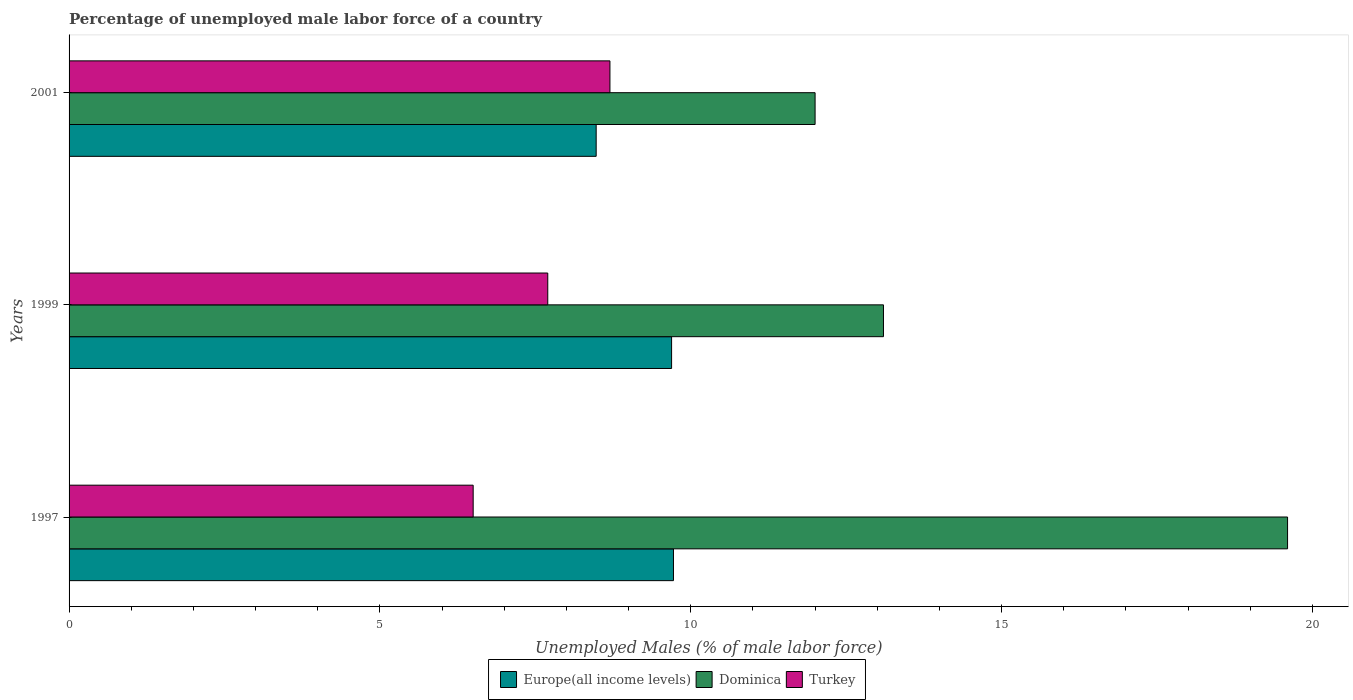How many different coloured bars are there?
Your answer should be compact. 3. How many groups of bars are there?
Your answer should be very brief. 3. Are the number of bars on each tick of the Y-axis equal?
Your answer should be compact. Yes. How many bars are there on the 2nd tick from the bottom?
Make the answer very short. 3. What is the label of the 3rd group of bars from the top?
Offer a very short reply. 1997. In how many cases, is the number of bars for a given year not equal to the number of legend labels?
Offer a very short reply. 0. What is the percentage of unemployed male labor force in Europe(all income levels) in 1997?
Give a very brief answer. 9.72. Across all years, what is the maximum percentage of unemployed male labor force in Dominica?
Ensure brevity in your answer.  19.6. Across all years, what is the minimum percentage of unemployed male labor force in Turkey?
Keep it short and to the point. 6.5. What is the total percentage of unemployed male labor force in Turkey in the graph?
Offer a very short reply. 22.9. What is the difference between the percentage of unemployed male labor force in Europe(all income levels) in 1997 and that in 1999?
Offer a very short reply. 0.03. What is the difference between the percentage of unemployed male labor force in Europe(all income levels) in 1997 and the percentage of unemployed male labor force in Dominica in 1999?
Offer a very short reply. -3.38. What is the average percentage of unemployed male labor force in Turkey per year?
Keep it short and to the point. 7.63. In the year 1999, what is the difference between the percentage of unemployed male labor force in Europe(all income levels) and percentage of unemployed male labor force in Turkey?
Ensure brevity in your answer.  1.99. What is the ratio of the percentage of unemployed male labor force in Europe(all income levels) in 1997 to that in 2001?
Offer a very short reply. 1.15. Is the percentage of unemployed male labor force in Turkey in 1997 less than that in 1999?
Make the answer very short. Yes. Is the difference between the percentage of unemployed male labor force in Europe(all income levels) in 1997 and 2001 greater than the difference between the percentage of unemployed male labor force in Turkey in 1997 and 2001?
Your answer should be compact. Yes. What is the difference between the highest and the second highest percentage of unemployed male labor force in Turkey?
Provide a succinct answer. 1. What is the difference between the highest and the lowest percentage of unemployed male labor force in Dominica?
Provide a succinct answer. 7.6. In how many years, is the percentage of unemployed male labor force in Dominica greater than the average percentage of unemployed male labor force in Dominica taken over all years?
Your answer should be very brief. 1. What does the 2nd bar from the bottom in 2001 represents?
Your answer should be compact. Dominica. Is it the case that in every year, the sum of the percentage of unemployed male labor force in Turkey and percentage of unemployed male labor force in Dominica is greater than the percentage of unemployed male labor force in Europe(all income levels)?
Your answer should be very brief. Yes. How many bars are there?
Offer a very short reply. 9. What is the difference between two consecutive major ticks on the X-axis?
Provide a short and direct response. 5. Does the graph contain any zero values?
Provide a succinct answer. No. Does the graph contain grids?
Offer a terse response. No. What is the title of the graph?
Offer a terse response. Percentage of unemployed male labor force of a country. What is the label or title of the X-axis?
Ensure brevity in your answer.  Unemployed Males (% of male labor force). What is the label or title of the Y-axis?
Your response must be concise. Years. What is the Unemployed Males (% of male labor force) of Europe(all income levels) in 1997?
Ensure brevity in your answer.  9.72. What is the Unemployed Males (% of male labor force) in Dominica in 1997?
Your answer should be compact. 19.6. What is the Unemployed Males (% of male labor force) of Turkey in 1997?
Ensure brevity in your answer.  6.5. What is the Unemployed Males (% of male labor force) of Europe(all income levels) in 1999?
Your answer should be compact. 9.69. What is the Unemployed Males (% of male labor force) in Dominica in 1999?
Offer a very short reply. 13.1. What is the Unemployed Males (% of male labor force) in Turkey in 1999?
Your response must be concise. 7.7. What is the Unemployed Males (% of male labor force) in Europe(all income levels) in 2001?
Ensure brevity in your answer.  8.48. What is the Unemployed Males (% of male labor force) in Turkey in 2001?
Offer a very short reply. 8.7. Across all years, what is the maximum Unemployed Males (% of male labor force) of Europe(all income levels)?
Your response must be concise. 9.72. Across all years, what is the maximum Unemployed Males (% of male labor force) of Dominica?
Give a very brief answer. 19.6. Across all years, what is the maximum Unemployed Males (% of male labor force) in Turkey?
Make the answer very short. 8.7. Across all years, what is the minimum Unemployed Males (% of male labor force) of Europe(all income levels)?
Give a very brief answer. 8.48. Across all years, what is the minimum Unemployed Males (% of male labor force) in Dominica?
Your response must be concise. 12. What is the total Unemployed Males (% of male labor force) of Europe(all income levels) in the graph?
Keep it short and to the point. 27.89. What is the total Unemployed Males (% of male labor force) in Dominica in the graph?
Make the answer very short. 44.7. What is the total Unemployed Males (% of male labor force) of Turkey in the graph?
Keep it short and to the point. 22.9. What is the difference between the Unemployed Males (% of male labor force) in Europe(all income levels) in 1997 and that in 1999?
Your response must be concise. 0.03. What is the difference between the Unemployed Males (% of male labor force) in Dominica in 1997 and that in 1999?
Offer a terse response. 6.5. What is the difference between the Unemployed Males (% of male labor force) in Turkey in 1997 and that in 1999?
Offer a very short reply. -1.2. What is the difference between the Unemployed Males (% of male labor force) of Europe(all income levels) in 1997 and that in 2001?
Offer a very short reply. 1.24. What is the difference between the Unemployed Males (% of male labor force) in Europe(all income levels) in 1999 and that in 2001?
Give a very brief answer. 1.21. What is the difference between the Unemployed Males (% of male labor force) of Dominica in 1999 and that in 2001?
Offer a very short reply. 1.1. What is the difference between the Unemployed Males (% of male labor force) of Turkey in 1999 and that in 2001?
Keep it short and to the point. -1. What is the difference between the Unemployed Males (% of male labor force) of Europe(all income levels) in 1997 and the Unemployed Males (% of male labor force) of Dominica in 1999?
Offer a very short reply. -3.38. What is the difference between the Unemployed Males (% of male labor force) in Europe(all income levels) in 1997 and the Unemployed Males (% of male labor force) in Turkey in 1999?
Your answer should be compact. 2.02. What is the difference between the Unemployed Males (% of male labor force) of Dominica in 1997 and the Unemployed Males (% of male labor force) of Turkey in 1999?
Make the answer very short. 11.9. What is the difference between the Unemployed Males (% of male labor force) in Europe(all income levels) in 1997 and the Unemployed Males (% of male labor force) in Dominica in 2001?
Provide a succinct answer. -2.28. What is the difference between the Unemployed Males (% of male labor force) of Europe(all income levels) in 1997 and the Unemployed Males (% of male labor force) of Turkey in 2001?
Provide a short and direct response. 1.02. What is the difference between the Unemployed Males (% of male labor force) in Europe(all income levels) in 1999 and the Unemployed Males (% of male labor force) in Dominica in 2001?
Give a very brief answer. -2.31. What is the average Unemployed Males (% of male labor force) of Europe(all income levels) per year?
Offer a very short reply. 9.3. What is the average Unemployed Males (% of male labor force) in Turkey per year?
Ensure brevity in your answer.  7.63. In the year 1997, what is the difference between the Unemployed Males (% of male labor force) of Europe(all income levels) and Unemployed Males (% of male labor force) of Dominica?
Your answer should be very brief. -9.88. In the year 1997, what is the difference between the Unemployed Males (% of male labor force) in Europe(all income levels) and Unemployed Males (% of male labor force) in Turkey?
Your answer should be very brief. 3.22. In the year 1997, what is the difference between the Unemployed Males (% of male labor force) in Dominica and Unemployed Males (% of male labor force) in Turkey?
Your answer should be very brief. 13.1. In the year 1999, what is the difference between the Unemployed Males (% of male labor force) in Europe(all income levels) and Unemployed Males (% of male labor force) in Dominica?
Ensure brevity in your answer.  -3.41. In the year 1999, what is the difference between the Unemployed Males (% of male labor force) in Europe(all income levels) and Unemployed Males (% of male labor force) in Turkey?
Provide a short and direct response. 1.99. In the year 1999, what is the difference between the Unemployed Males (% of male labor force) of Dominica and Unemployed Males (% of male labor force) of Turkey?
Provide a succinct answer. 5.4. In the year 2001, what is the difference between the Unemployed Males (% of male labor force) in Europe(all income levels) and Unemployed Males (% of male labor force) in Dominica?
Keep it short and to the point. -3.52. In the year 2001, what is the difference between the Unemployed Males (% of male labor force) in Europe(all income levels) and Unemployed Males (% of male labor force) in Turkey?
Keep it short and to the point. -0.22. What is the ratio of the Unemployed Males (% of male labor force) of Europe(all income levels) in 1997 to that in 1999?
Your answer should be very brief. 1. What is the ratio of the Unemployed Males (% of male labor force) of Dominica in 1997 to that in 1999?
Ensure brevity in your answer.  1.5. What is the ratio of the Unemployed Males (% of male labor force) in Turkey in 1997 to that in 1999?
Your answer should be compact. 0.84. What is the ratio of the Unemployed Males (% of male labor force) of Europe(all income levels) in 1997 to that in 2001?
Offer a very short reply. 1.15. What is the ratio of the Unemployed Males (% of male labor force) in Dominica in 1997 to that in 2001?
Your answer should be very brief. 1.63. What is the ratio of the Unemployed Males (% of male labor force) of Turkey in 1997 to that in 2001?
Provide a short and direct response. 0.75. What is the ratio of the Unemployed Males (% of male labor force) in Europe(all income levels) in 1999 to that in 2001?
Your answer should be compact. 1.14. What is the ratio of the Unemployed Males (% of male labor force) of Dominica in 1999 to that in 2001?
Make the answer very short. 1.09. What is the ratio of the Unemployed Males (% of male labor force) of Turkey in 1999 to that in 2001?
Your answer should be very brief. 0.89. What is the difference between the highest and the second highest Unemployed Males (% of male labor force) of Europe(all income levels)?
Make the answer very short. 0.03. What is the difference between the highest and the second highest Unemployed Males (% of male labor force) of Turkey?
Offer a terse response. 1. What is the difference between the highest and the lowest Unemployed Males (% of male labor force) in Europe(all income levels)?
Make the answer very short. 1.24. What is the difference between the highest and the lowest Unemployed Males (% of male labor force) of Turkey?
Offer a very short reply. 2.2. 